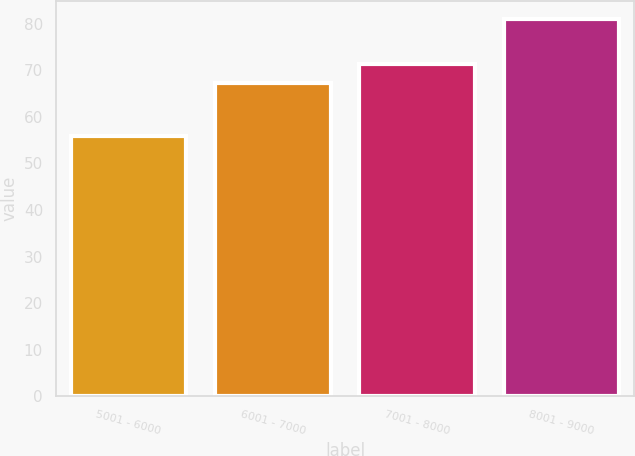Convert chart. <chart><loc_0><loc_0><loc_500><loc_500><bar_chart><fcel>5001 - 6000<fcel>6001 - 7000<fcel>7001 - 8000<fcel>8001 - 9000<nl><fcel>55.83<fcel>67.18<fcel>71.43<fcel>80.91<nl></chart> 